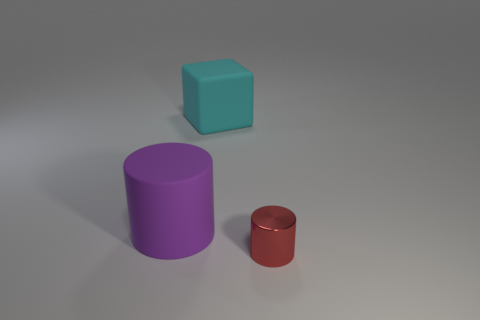What size is the red cylinder?
Provide a succinct answer. Small. Are there the same number of red things on the right side of the red metal cylinder and large red cylinders?
Provide a succinct answer. Yes. What number of other things are the same color as the large matte cylinder?
Make the answer very short. 0. There is a object that is in front of the large cyan matte object and to the right of the big purple rubber thing; what color is it?
Make the answer very short. Red. There is a object that is to the right of the rubber object behind the cylinder that is on the left side of the small red thing; what is its size?
Offer a very short reply. Small. What number of objects are either cylinders that are behind the red metal object or big rubber objects on the left side of the cyan rubber cube?
Provide a succinct answer. 1. The large cyan thing is what shape?
Provide a short and direct response. Cube. How many other things are made of the same material as the big cube?
Provide a succinct answer. 1. What size is the other purple object that is the same shape as the small object?
Ensure brevity in your answer.  Large. There is a thing behind the cylinder to the left of the small cylinder that is in front of the rubber cylinder; what is its material?
Make the answer very short. Rubber. 